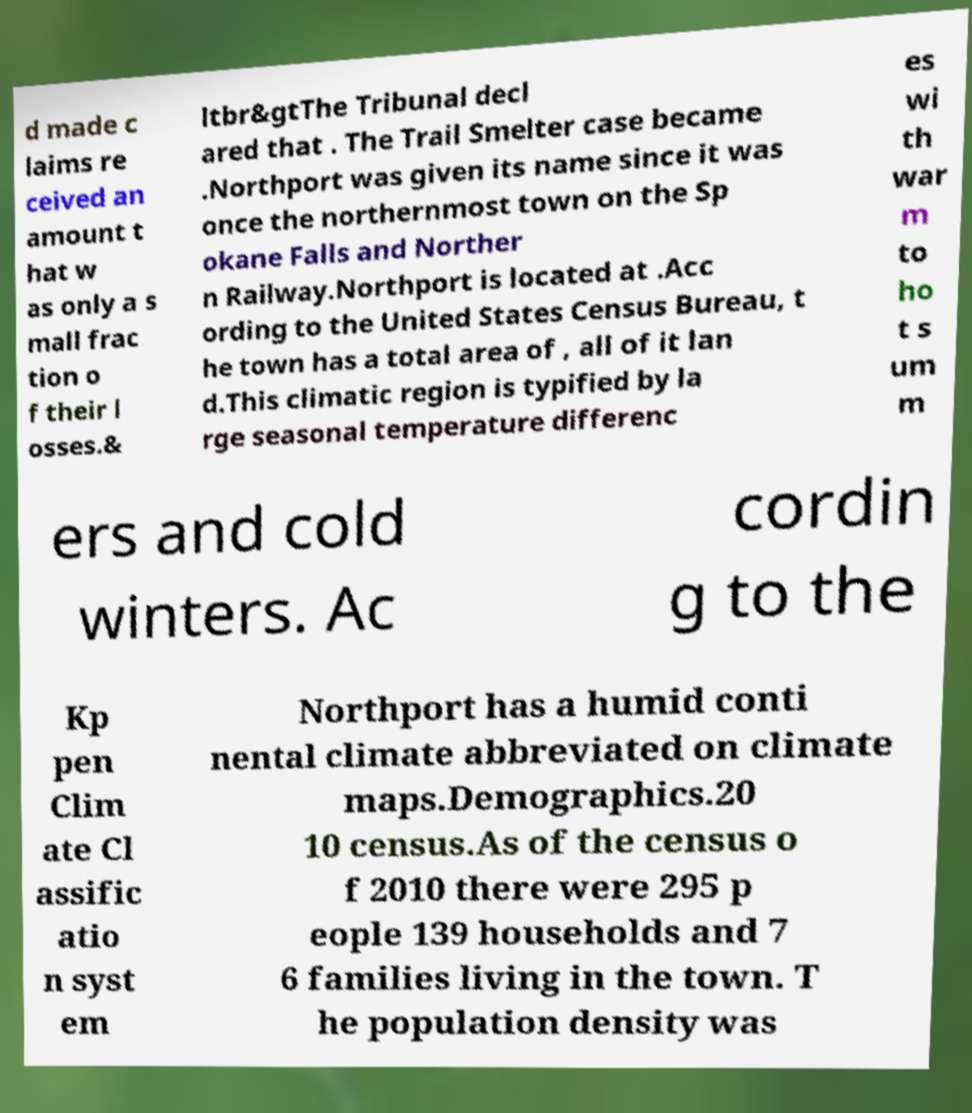Can you read and provide the text displayed in the image?This photo seems to have some interesting text. Can you extract and type it out for me? d made c laims re ceived an amount t hat w as only a s mall frac tion o f their l osses.& ltbr&gtThe Tribunal decl ared that . The Trail Smelter case became .Northport was given its name since it was once the northernmost town on the Sp okane Falls and Norther n Railway.Northport is located at .Acc ording to the United States Census Bureau, t he town has a total area of , all of it lan d.This climatic region is typified by la rge seasonal temperature differenc es wi th war m to ho t s um m ers and cold winters. Ac cordin g to the Kp pen Clim ate Cl assific atio n syst em Northport has a humid conti nental climate abbreviated on climate maps.Demographics.20 10 census.As of the census o f 2010 there were 295 p eople 139 households and 7 6 families living in the town. T he population density was 